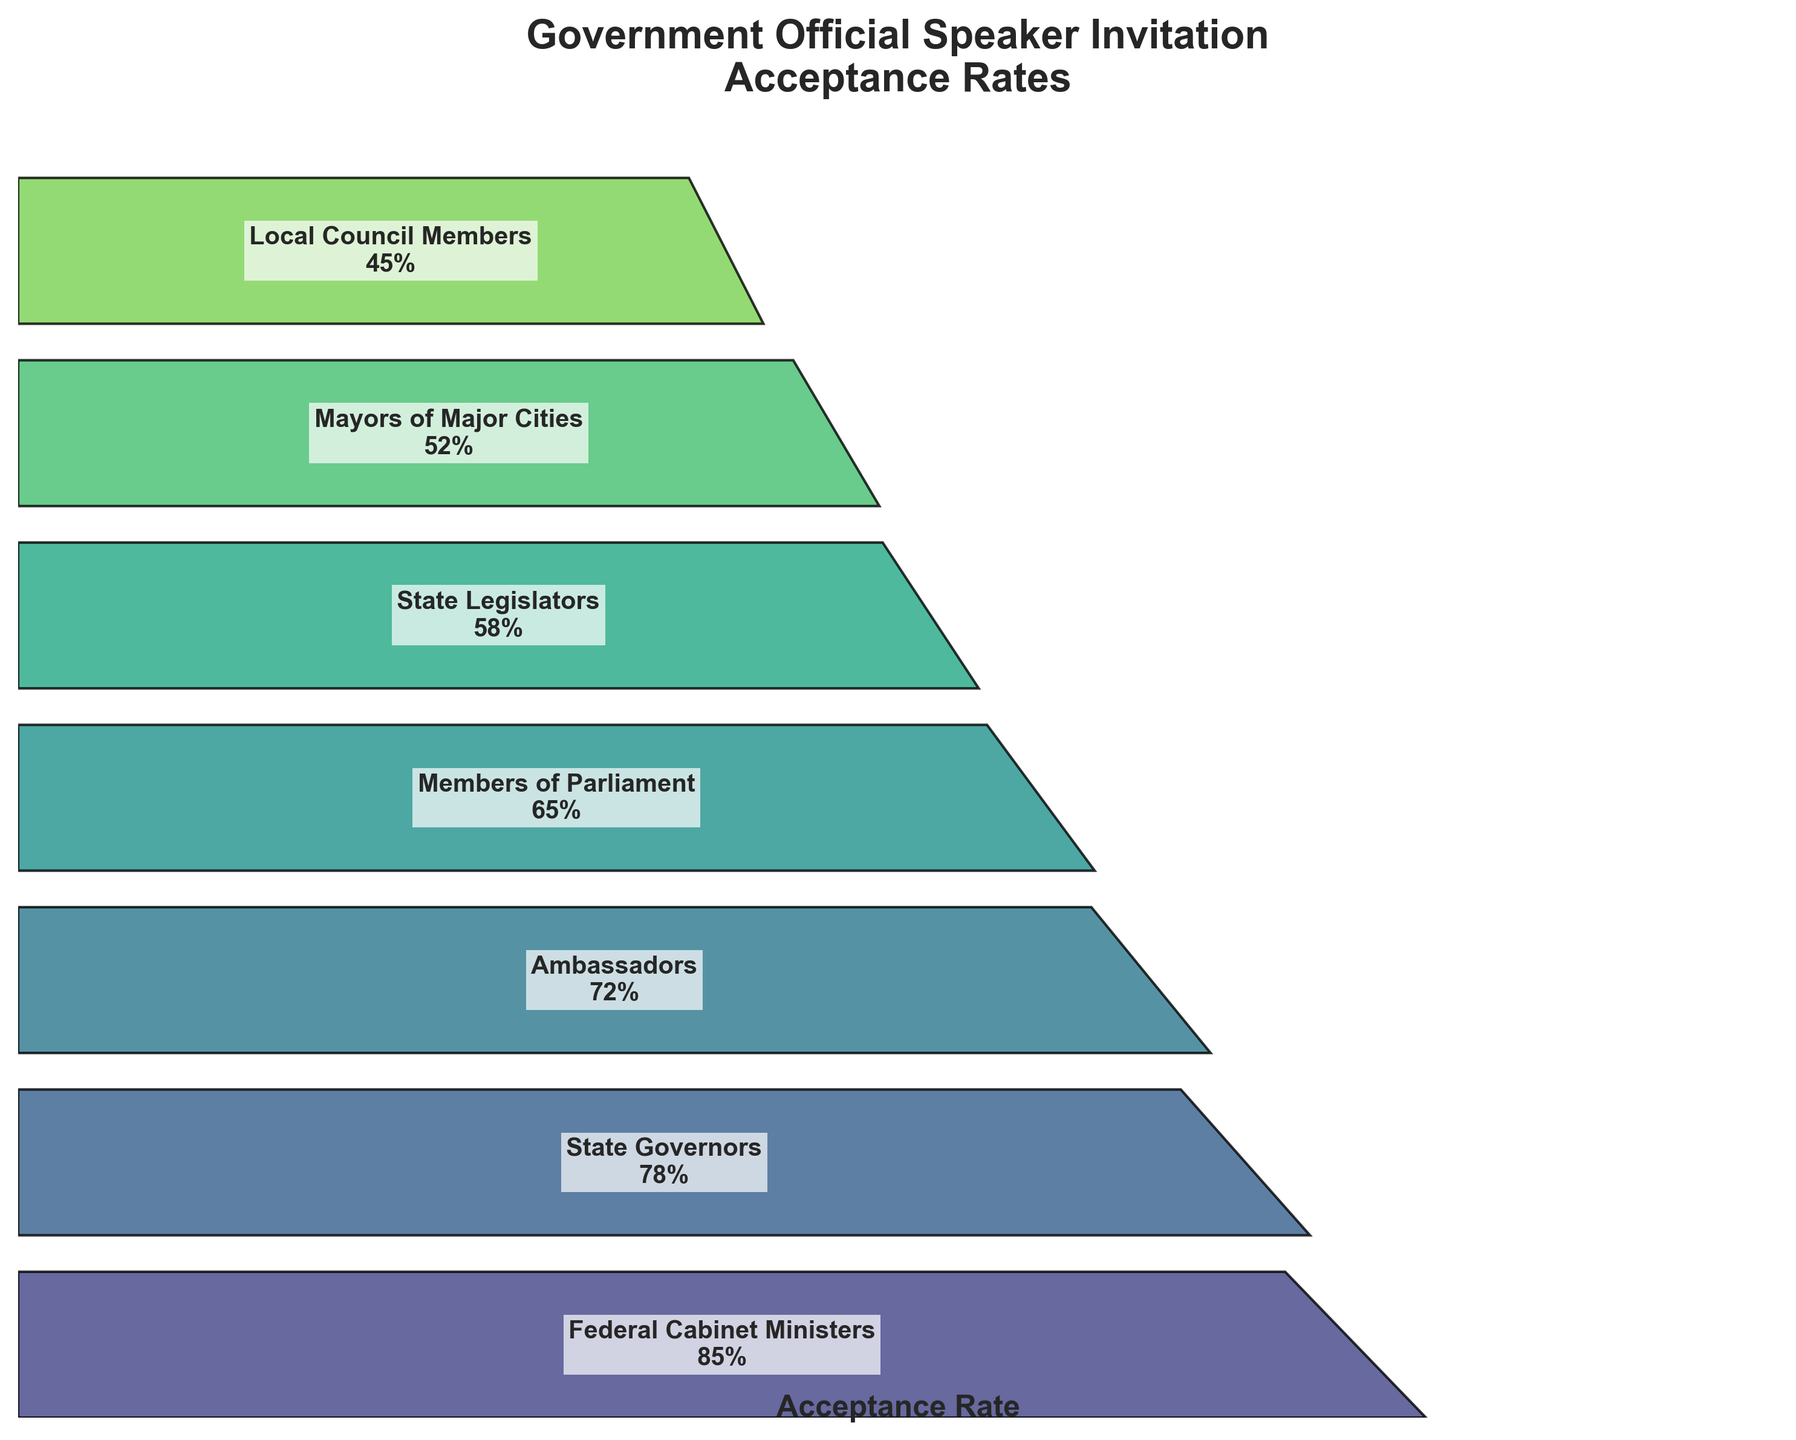How many stages are shown in the funnel chart? The funnel chart displays different stages, each representing a level of government officials. The stages are presented vertically. Simply count the number of distinct stages.
Answer: 7 Which government official level has the highest acceptance rate? Look at the top-most level of the funnel chart, which represents the highest acceptance rate. The text inside the polygon at this stage shows the rate and the level.
Answer: Federal Cabinet Ministers What is the acceptance rate for State Governors? Find the polygon labeled "State Governors" in the funnel chart. The acceptance rate is displayed within the text in this polygon.
Answer: 78% Which two levels of government officials have the smallest acceptance rates? Look at the bottom two polygons in the funnel chart. The acceptance rates and levels are displayed in these polygons.
Answer: Mayors of Major Cities and Local Council Members How much greater is the acceptance rate of Ambassadors compared to State Legislators? Find the text labels for Ambassadors and State Legislators in the funnel chart. Subtract the acceptance rate of State Legislators from the acceptance rate of Ambassadors using their respective percentages.
Answer: 14% What is the combined acceptance rate of Federal Cabinet Ministers, State Governors, and Ambassadors? Identify the acceptance rates for Federal Cabinet Ministers, State Governors, and Ambassadors. Add these three percentages together (85% + 78% + 72%).
Answer: 235% What is the difference in acceptance rate between Members of Parliament and Mayors of Major Cities? Locate the acceptance rates for Members of Parliament and Mayors of Major Cities in the funnel chart. Subtract the acceptance rate of Mayors of Major Cities from the acceptance rate of Members of Parliament.
Answer: 13% Which level has an acceptance rate closest to 50%? Look at the percentages listed in the funnel chart and find the one closest to 50%. This can be determined visually.
Answer: Mayors of Major Cities How does the acceptance rate trend as the administrative level shifts from higher to lower? Examine the shape and arrangement of the funnel chart, starting from the top (highest levels) to the bottom (lower levels). Describe the pattern in the acceptance rates.
Answer: Decreases Based on the funnel chart, which two government official levels have an acceptance rate difference of 30%? Search for two stages whose acceptance rate difference is 30%. Calculate differences between adjacent stages until the correct pair is found. The difference occurs between Federal Cabinet Ministers (85%) and State Legislators (55%).
Answer: Federal Cabinet Ministers and State Legislators 